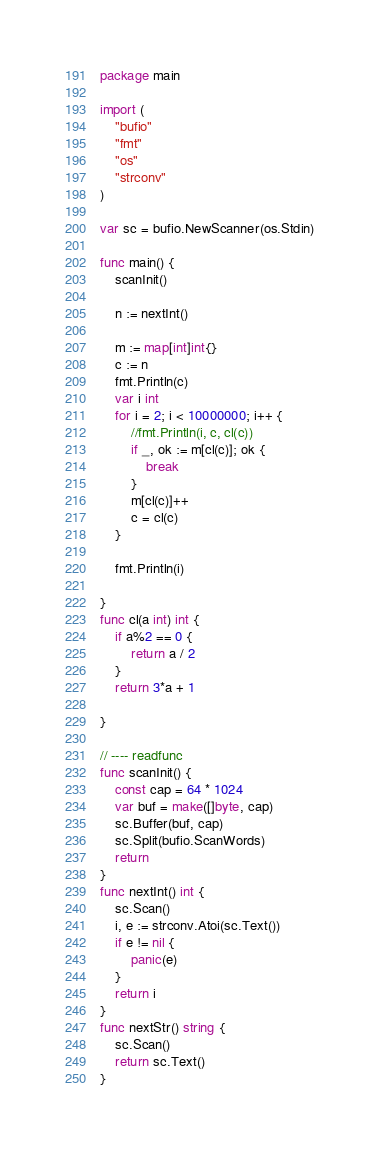Convert code to text. <code><loc_0><loc_0><loc_500><loc_500><_Go_>package main

import (
	"bufio"
	"fmt"
	"os"
	"strconv"
)

var sc = bufio.NewScanner(os.Stdin)

func main() {
	scanInit()

	n := nextInt()

	m := map[int]int{}
	c := n
	fmt.Println(c)
	var i int
	for i = 2; i < 10000000; i++ {
		//fmt.Println(i, c, cl(c))
		if _, ok := m[cl(c)]; ok {
			break
		}
		m[cl(c)]++
		c = cl(c)
	}

	fmt.Println(i)

}
func cl(a int) int {
	if a%2 == 0 {
		return a / 2
	}
	return 3*a + 1

}

// ---- readfunc
func scanInit() {
	const cap = 64 * 1024
	var buf = make([]byte, cap)
	sc.Buffer(buf, cap)
	sc.Split(bufio.ScanWords)
	return
}
func nextInt() int {
	sc.Scan()
	i, e := strconv.Atoi(sc.Text())
	if e != nil {
		panic(e)
	}
	return i
}
func nextStr() string {
	sc.Scan()
	return sc.Text()
}
</code> 